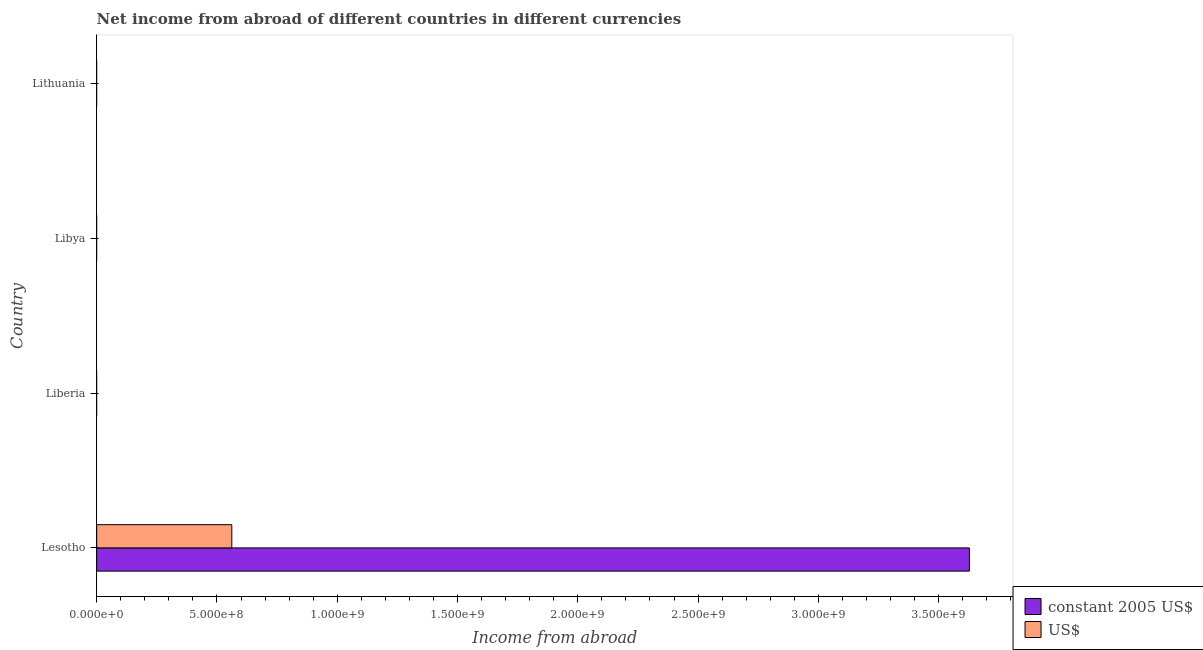How many different coloured bars are there?
Keep it short and to the point. 2. Are the number of bars per tick equal to the number of legend labels?
Provide a short and direct response. No. How many bars are there on the 1st tick from the bottom?
Offer a terse response. 2. What is the label of the 4th group of bars from the top?
Provide a short and direct response. Lesotho. What is the income from abroad in constant 2005 us$ in Liberia?
Make the answer very short. 0. Across all countries, what is the maximum income from abroad in constant 2005 us$?
Offer a terse response. 3.63e+09. Across all countries, what is the minimum income from abroad in constant 2005 us$?
Your answer should be very brief. 0. In which country was the income from abroad in constant 2005 us$ maximum?
Keep it short and to the point. Lesotho. What is the total income from abroad in constant 2005 us$ in the graph?
Give a very brief answer. 3.63e+09. What is the difference between the income from abroad in constant 2005 us$ in Lesotho and the income from abroad in us$ in Liberia?
Provide a succinct answer. 3.63e+09. What is the average income from abroad in constant 2005 us$ per country?
Offer a terse response. 9.07e+08. What is the difference between the income from abroad in us$ and income from abroad in constant 2005 us$ in Lesotho?
Ensure brevity in your answer.  -3.07e+09. In how many countries, is the income from abroad in constant 2005 us$ greater than 2700000000 units?
Offer a terse response. 1. What is the difference between the highest and the lowest income from abroad in constant 2005 us$?
Keep it short and to the point. 3.63e+09. Does the graph contain grids?
Your response must be concise. No. Where does the legend appear in the graph?
Your response must be concise. Bottom right. How many legend labels are there?
Keep it short and to the point. 2. How are the legend labels stacked?
Offer a terse response. Vertical. What is the title of the graph?
Offer a terse response. Net income from abroad of different countries in different currencies. What is the label or title of the X-axis?
Provide a short and direct response. Income from abroad. What is the Income from abroad in constant 2005 US$ in Lesotho?
Provide a succinct answer. 3.63e+09. What is the Income from abroad of US$ in Lesotho?
Keep it short and to the point. 5.62e+08. What is the Income from abroad of US$ in Liberia?
Your answer should be very brief. 0. What is the Income from abroad of constant 2005 US$ in Lithuania?
Provide a succinct answer. 0. Across all countries, what is the maximum Income from abroad in constant 2005 US$?
Your response must be concise. 3.63e+09. Across all countries, what is the maximum Income from abroad in US$?
Your answer should be compact. 5.62e+08. What is the total Income from abroad in constant 2005 US$ in the graph?
Make the answer very short. 3.63e+09. What is the total Income from abroad in US$ in the graph?
Your response must be concise. 5.62e+08. What is the average Income from abroad in constant 2005 US$ per country?
Provide a succinct answer. 9.07e+08. What is the average Income from abroad of US$ per country?
Offer a terse response. 1.40e+08. What is the difference between the Income from abroad of constant 2005 US$ and Income from abroad of US$ in Lesotho?
Provide a succinct answer. 3.07e+09. What is the difference between the highest and the lowest Income from abroad in constant 2005 US$?
Your answer should be very brief. 3.63e+09. What is the difference between the highest and the lowest Income from abroad of US$?
Your answer should be very brief. 5.62e+08. 